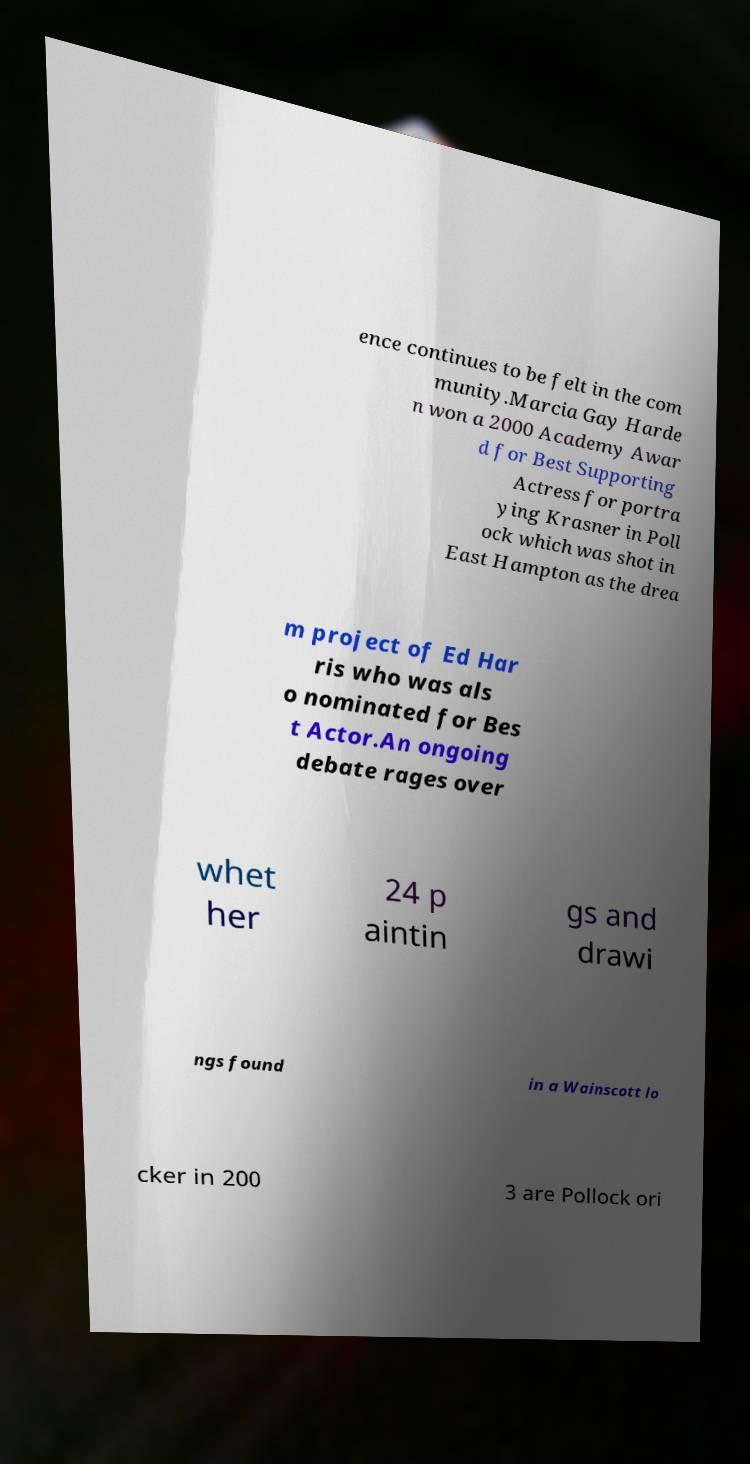Please identify and transcribe the text found in this image. ence continues to be felt in the com munity.Marcia Gay Harde n won a 2000 Academy Awar d for Best Supporting Actress for portra ying Krasner in Poll ock which was shot in East Hampton as the drea m project of Ed Har ris who was als o nominated for Bes t Actor.An ongoing debate rages over whet her 24 p aintin gs and drawi ngs found in a Wainscott lo cker in 200 3 are Pollock ori 